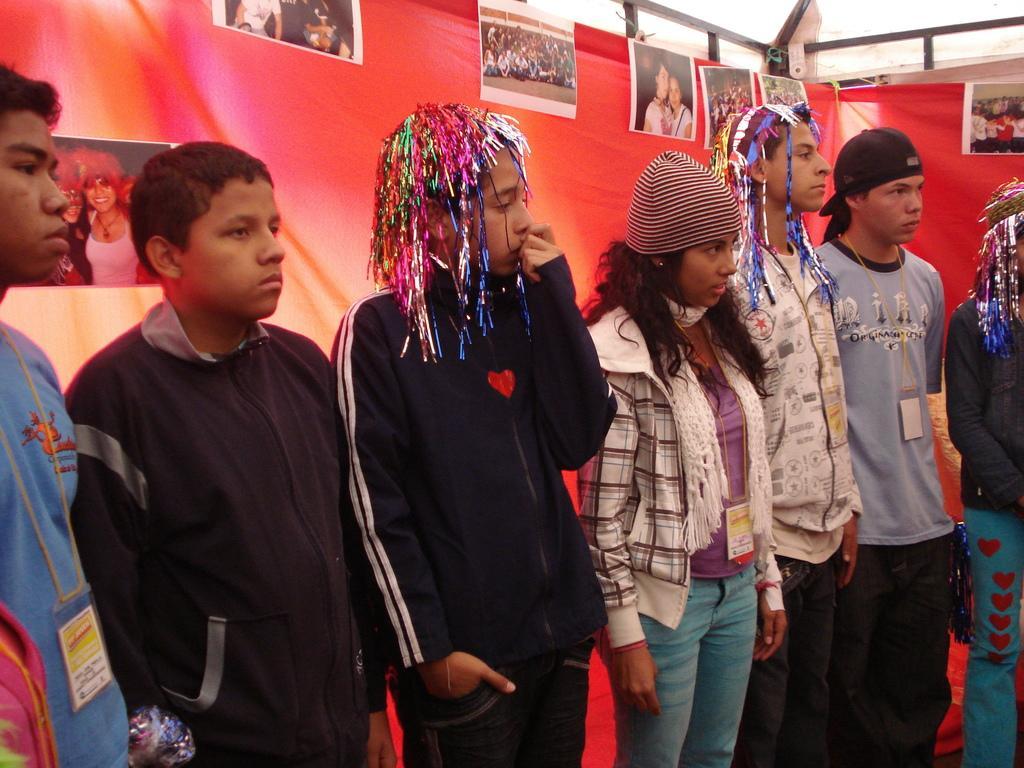Could you give a brief overview of what you see in this image? In this image we can see few people standing. Some are wearing caps. And some are wearing tags. In the back there is a cloth with photos pasted on that. 